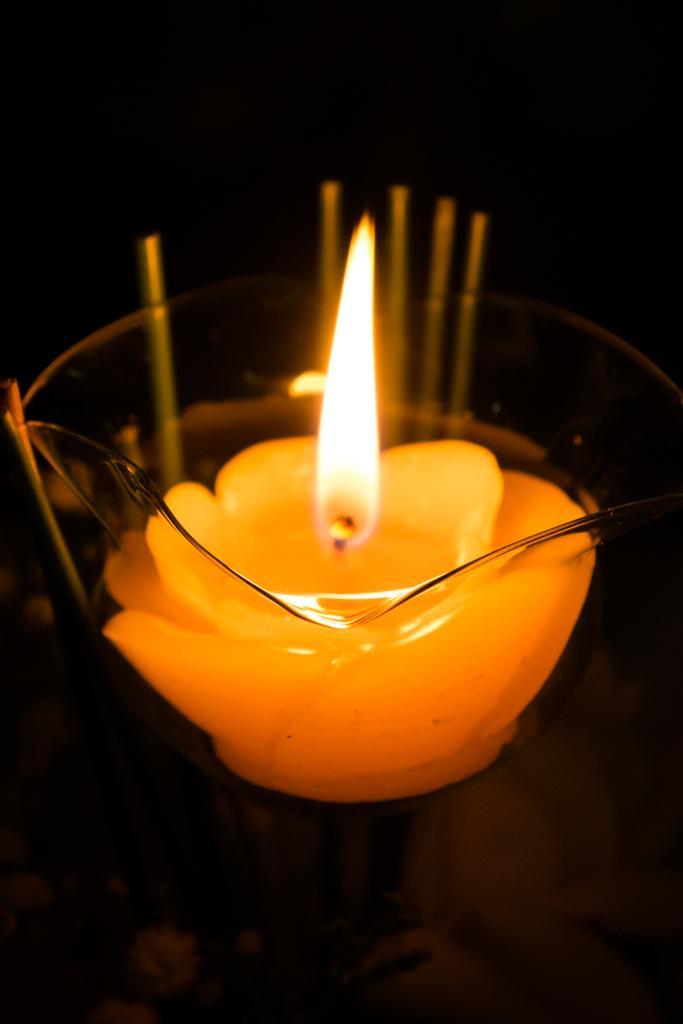Describe this image in one or two sentences. In this image I can see a glass bowl and in it I can see a candle which is yellow and orange in color. I can see the black colored background. 